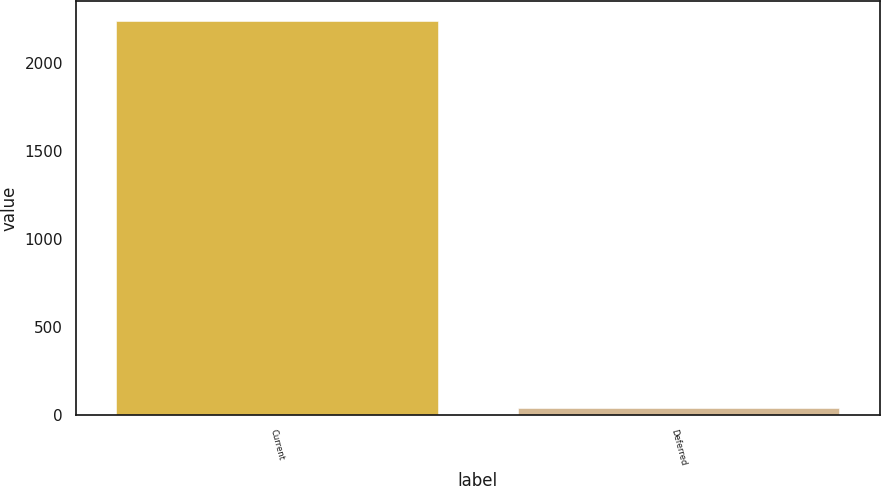Convert chart. <chart><loc_0><loc_0><loc_500><loc_500><bar_chart><fcel>Current<fcel>Deferred<nl><fcel>2241<fcel>40<nl></chart> 